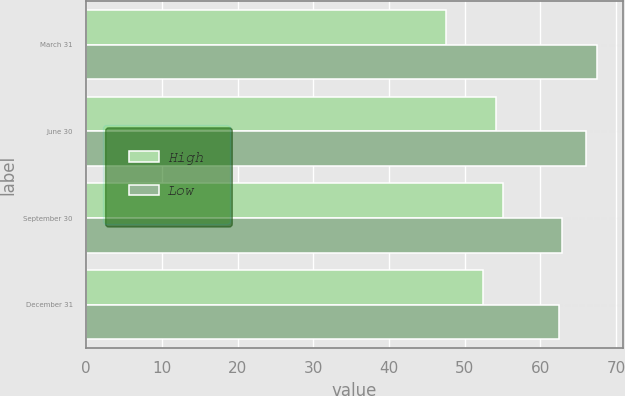Convert chart. <chart><loc_0><loc_0><loc_500><loc_500><stacked_bar_chart><ecel><fcel>March 31<fcel>June 30<fcel>September 30<fcel>December 31<nl><fcel>High<fcel>47.54<fcel>54.12<fcel>55.09<fcel>52.4<nl><fcel>Low<fcel>67.49<fcel>66.07<fcel>62.85<fcel>62.49<nl></chart> 